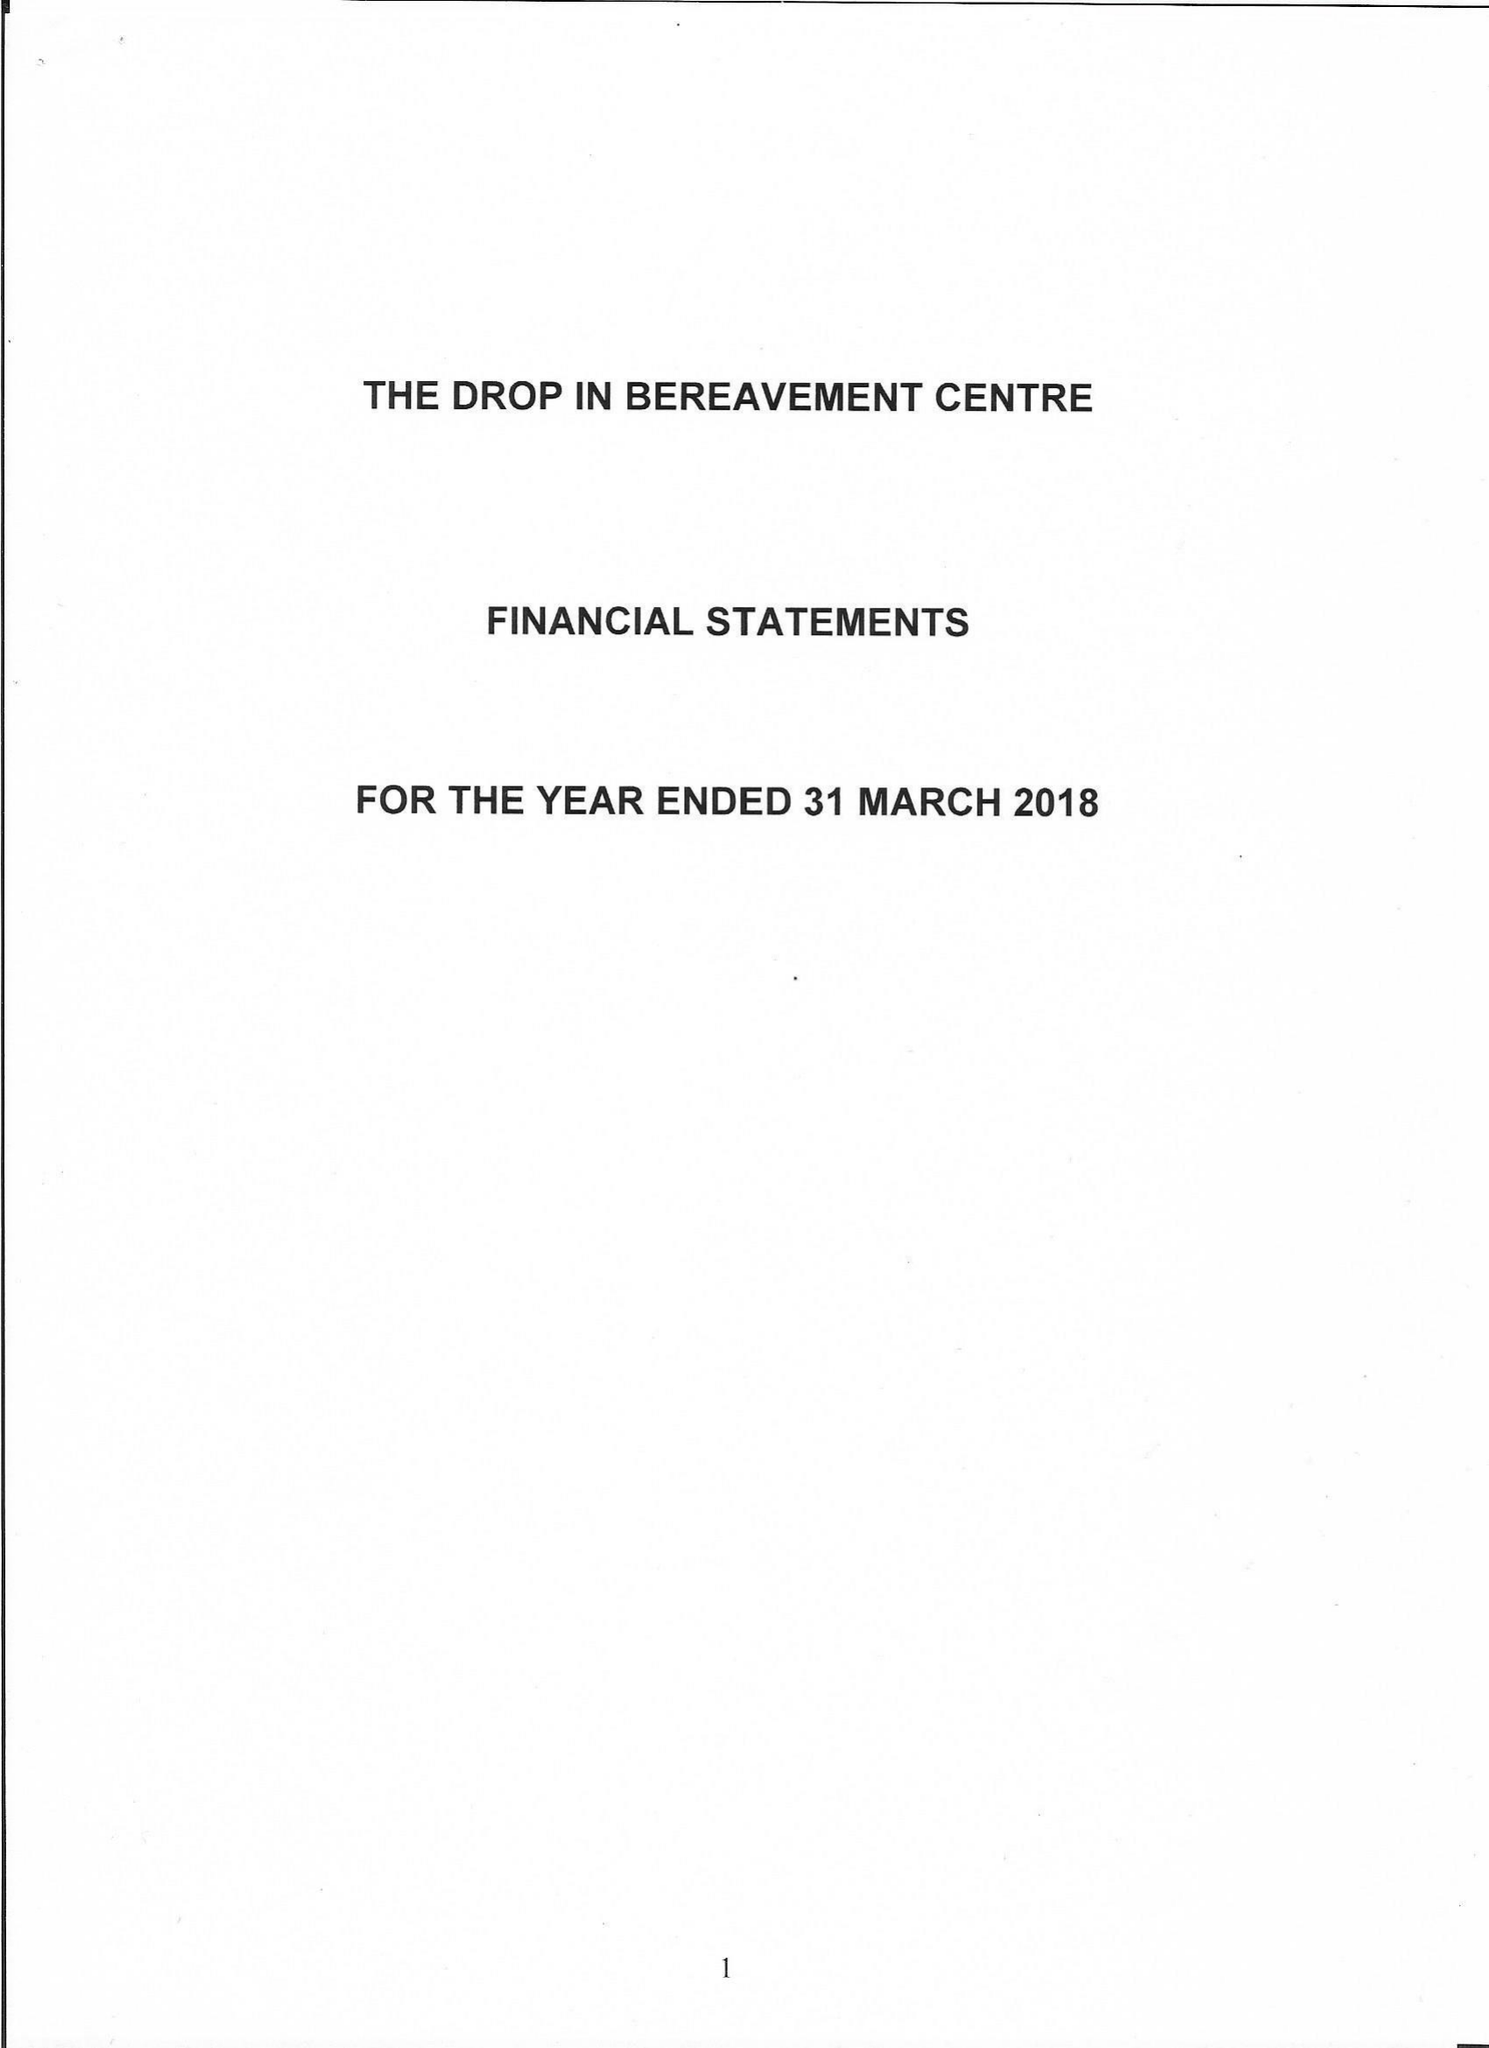What is the value for the report_date?
Answer the question using a single word or phrase. 2018-03-31 